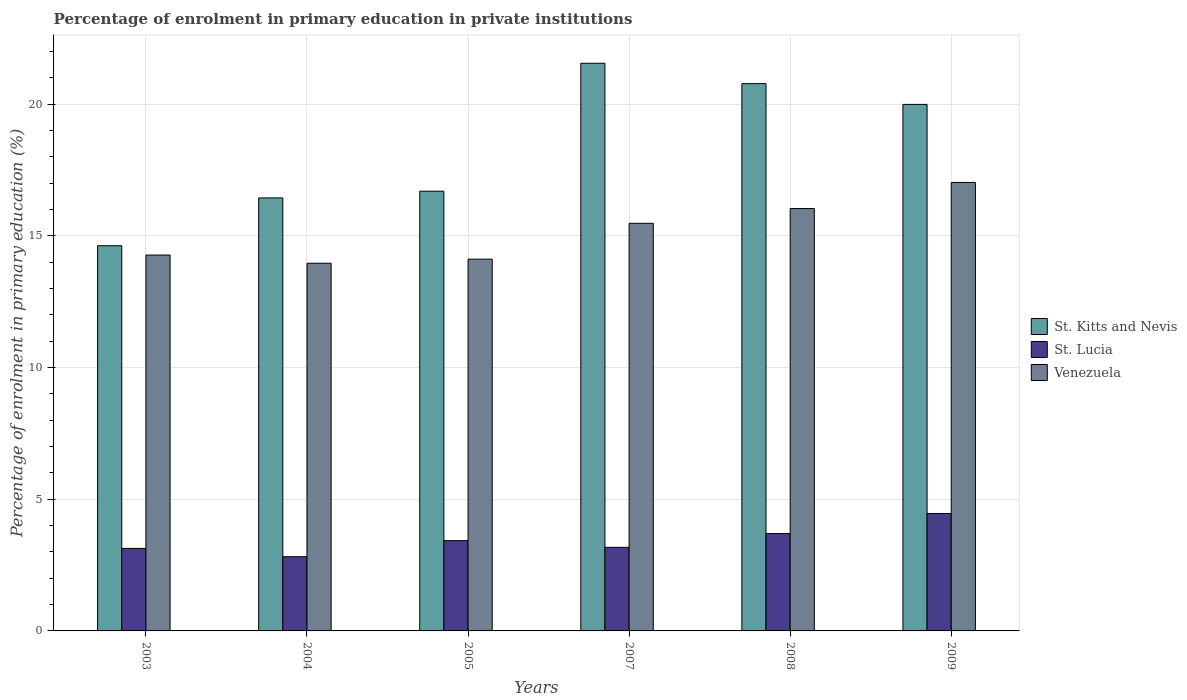How many groups of bars are there?
Your answer should be compact. 6. What is the percentage of enrolment in primary education in St. Kitts and Nevis in 2008?
Ensure brevity in your answer.  20.78. Across all years, what is the maximum percentage of enrolment in primary education in St. Kitts and Nevis?
Offer a terse response. 21.55. Across all years, what is the minimum percentage of enrolment in primary education in St. Kitts and Nevis?
Your answer should be very brief. 14.62. In which year was the percentage of enrolment in primary education in St. Kitts and Nevis minimum?
Make the answer very short. 2003. What is the total percentage of enrolment in primary education in St. Lucia in the graph?
Your answer should be compact. 20.71. What is the difference between the percentage of enrolment in primary education in Venezuela in 2003 and that in 2009?
Your answer should be very brief. -2.76. What is the difference between the percentage of enrolment in primary education in St. Kitts and Nevis in 2005 and the percentage of enrolment in primary education in St. Lucia in 2004?
Keep it short and to the point. 13.88. What is the average percentage of enrolment in primary education in Venezuela per year?
Offer a terse response. 15.15. In the year 2004, what is the difference between the percentage of enrolment in primary education in Venezuela and percentage of enrolment in primary education in St. Lucia?
Make the answer very short. 11.14. In how many years, is the percentage of enrolment in primary education in St. Lucia greater than 20 %?
Keep it short and to the point. 0. What is the ratio of the percentage of enrolment in primary education in St. Kitts and Nevis in 2003 to that in 2007?
Your answer should be very brief. 0.68. Is the percentage of enrolment in primary education in St. Kitts and Nevis in 2003 less than that in 2009?
Provide a succinct answer. Yes. What is the difference between the highest and the second highest percentage of enrolment in primary education in St. Lucia?
Your answer should be very brief. 0.76. What is the difference between the highest and the lowest percentage of enrolment in primary education in St. Kitts and Nevis?
Offer a terse response. 6.93. Is the sum of the percentage of enrolment in primary education in St. Lucia in 2003 and 2008 greater than the maximum percentage of enrolment in primary education in St. Kitts and Nevis across all years?
Keep it short and to the point. No. What does the 1st bar from the left in 2008 represents?
Make the answer very short. St. Kitts and Nevis. What does the 1st bar from the right in 2004 represents?
Give a very brief answer. Venezuela. How many bars are there?
Give a very brief answer. 18. Are all the bars in the graph horizontal?
Ensure brevity in your answer.  No. How many years are there in the graph?
Offer a very short reply. 6. What is the difference between two consecutive major ticks on the Y-axis?
Give a very brief answer. 5. Where does the legend appear in the graph?
Give a very brief answer. Center right. How many legend labels are there?
Ensure brevity in your answer.  3. What is the title of the graph?
Offer a very short reply. Percentage of enrolment in primary education in private institutions. Does "Jordan" appear as one of the legend labels in the graph?
Provide a short and direct response. No. What is the label or title of the X-axis?
Provide a succinct answer. Years. What is the label or title of the Y-axis?
Ensure brevity in your answer.  Percentage of enrolment in primary education (%). What is the Percentage of enrolment in primary education (%) in St. Kitts and Nevis in 2003?
Your answer should be compact. 14.62. What is the Percentage of enrolment in primary education (%) in St. Lucia in 2003?
Keep it short and to the point. 3.13. What is the Percentage of enrolment in primary education (%) in Venezuela in 2003?
Give a very brief answer. 14.27. What is the Percentage of enrolment in primary education (%) in St. Kitts and Nevis in 2004?
Your answer should be very brief. 16.44. What is the Percentage of enrolment in primary education (%) in St. Lucia in 2004?
Your answer should be very brief. 2.82. What is the Percentage of enrolment in primary education (%) in Venezuela in 2004?
Ensure brevity in your answer.  13.96. What is the Percentage of enrolment in primary education (%) in St. Kitts and Nevis in 2005?
Your answer should be compact. 16.69. What is the Percentage of enrolment in primary education (%) of St. Lucia in 2005?
Provide a succinct answer. 3.43. What is the Percentage of enrolment in primary education (%) of Venezuela in 2005?
Provide a succinct answer. 14.11. What is the Percentage of enrolment in primary education (%) in St. Kitts and Nevis in 2007?
Provide a succinct answer. 21.55. What is the Percentage of enrolment in primary education (%) in St. Lucia in 2007?
Make the answer very short. 3.17. What is the Percentage of enrolment in primary education (%) in Venezuela in 2007?
Give a very brief answer. 15.47. What is the Percentage of enrolment in primary education (%) of St. Kitts and Nevis in 2008?
Offer a very short reply. 20.78. What is the Percentage of enrolment in primary education (%) in St. Lucia in 2008?
Make the answer very short. 3.7. What is the Percentage of enrolment in primary education (%) of Venezuela in 2008?
Provide a succinct answer. 16.03. What is the Percentage of enrolment in primary education (%) of St. Kitts and Nevis in 2009?
Offer a very short reply. 19.99. What is the Percentage of enrolment in primary education (%) of St. Lucia in 2009?
Offer a very short reply. 4.46. What is the Percentage of enrolment in primary education (%) of Venezuela in 2009?
Your answer should be compact. 17.03. Across all years, what is the maximum Percentage of enrolment in primary education (%) in St. Kitts and Nevis?
Your answer should be very brief. 21.55. Across all years, what is the maximum Percentage of enrolment in primary education (%) of St. Lucia?
Offer a terse response. 4.46. Across all years, what is the maximum Percentage of enrolment in primary education (%) of Venezuela?
Provide a short and direct response. 17.03. Across all years, what is the minimum Percentage of enrolment in primary education (%) of St. Kitts and Nevis?
Your response must be concise. 14.62. Across all years, what is the minimum Percentage of enrolment in primary education (%) in St. Lucia?
Ensure brevity in your answer.  2.82. Across all years, what is the minimum Percentage of enrolment in primary education (%) of Venezuela?
Your response must be concise. 13.96. What is the total Percentage of enrolment in primary education (%) of St. Kitts and Nevis in the graph?
Offer a terse response. 110.06. What is the total Percentage of enrolment in primary education (%) of St. Lucia in the graph?
Your answer should be compact. 20.71. What is the total Percentage of enrolment in primary education (%) in Venezuela in the graph?
Your answer should be very brief. 90.87. What is the difference between the Percentage of enrolment in primary education (%) of St. Kitts and Nevis in 2003 and that in 2004?
Keep it short and to the point. -1.81. What is the difference between the Percentage of enrolment in primary education (%) of St. Lucia in 2003 and that in 2004?
Offer a terse response. 0.32. What is the difference between the Percentage of enrolment in primary education (%) of Venezuela in 2003 and that in 2004?
Ensure brevity in your answer.  0.31. What is the difference between the Percentage of enrolment in primary education (%) of St. Kitts and Nevis in 2003 and that in 2005?
Your response must be concise. -2.07. What is the difference between the Percentage of enrolment in primary education (%) of St. Lucia in 2003 and that in 2005?
Ensure brevity in your answer.  -0.29. What is the difference between the Percentage of enrolment in primary education (%) of Venezuela in 2003 and that in 2005?
Your answer should be very brief. 0.16. What is the difference between the Percentage of enrolment in primary education (%) of St. Kitts and Nevis in 2003 and that in 2007?
Your answer should be very brief. -6.93. What is the difference between the Percentage of enrolment in primary education (%) in St. Lucia in 2003 and that in 2007?
Your response must be concise. -0.04. What is the difference between the Percentage of enrolment in primary education (%) of Venezuela in 2003 and that in 2007?
Your answer should be very brief. -1.21. What is the difference between the Percentage of enrolment in primary education (%) of St. Kitts and Nevis in 2003 and that in 2008?
Provide a short and direct response. -6.15. What is the difference between the Percentage of enrolment in primary education (%) in St. Lucia in 2003 and that in 2008?
Your answer should be very brief. -0.56. What is the difference between the Percentage of enrolment in primary education (%) of Venezuela in 2003 and that in 2008?
Offer a very short reply. -1.76. What is the difference between the Percentage of enrolment in primary education (%) in St. Kitts and Nevis in 2003 and that in 2009?
Your answer should be compact. -5.36. What is the difference between the Percentage of enrolment in primary education (%) in St. Lucia in 2003 and that in 2009?
Ensure brevity in your answer.  -1.32. What is the difference between the Percentage of enrolment in primary education (%) of Venezuela in 2003 and that in 2009?
Offer a terse response. -2.76. What is the difference between the Percentage of enrolment in primary education (%) in St. Kitts and Nevis in 2004 and that in 2005?
Offer a terse response. -0.26. What is the difference between the Percentage of enrolment in primary education (%) in St. Lucia in 2004 and that in 2005?
Keep it short and to the point. -0.61. What is the difference between the Percentage of enrolment in primary education (%) in Venezuela in 2004 and that in 2005?
Provide a succinct answer. -0.16. What is the difference between the Percentage of enrolment in primary education (%) in St. Kitts and Nevis in 2004 and that in 2007?
Give a very brief answer. -5.11. What is the difference between the Percentage of enrolment in primary education (%) of St. Lucia in 2004 and that in 2007?
Keep it short and to the point. -0.36. What is the difference between the Percentage of enrolment in primary education (%) of Venezuela in 2004 and that in 2007?
Ensure brevity in your answer.  -1.52. What is the difference between the Percentage of enrolment in primary education (%) of St. Kitts and Nevis in 2004 and that in 2008?
Make the answer very short. -4.34. What is the difference between the Percentage of enrolment in primary education (%) of St. Lucia in 2004 and that in 2008?
Your answer should be compact. -0.88. What is the difference between the Percentage of enrolment in primary education (%) of Venezuela in 2004 and that in 2008?
Your answer should be very brief. -2.08. What is the difference between the Percentage of enrolment in primary education (%) of St. Kitts and Nevis in 2004 and that in 2009?
Your answer should be compact. -3.55. What is the difference between the Percentage of enrolment in primary education (%) in St. Lucia in 2004 and that in 2009?
Provide a short and direct response. -1.64. What is the difference between the Percentage of enrolment in primary education (%) of Venezuela in 2004 and that in 2009?
Give a very brief answer. -3.07. What is the difference between the Percentage of enrolment in primary education (%) in St. Kitts and Nevis in 2005 and that in 2007?
Your answer should be compact. -4.86. What is the difference between the Percentage of enrolment in primary education (%) of St. Lucia in 2005 and that in 2007?
Keep it short and to the point. 0.25. What is the difference between the Percentage of enrolment in primary education (%) in Venezuela in 2005 and that in 2007?
Your answer should be compact. -1.36. What is the difference between the Percentage of enrolment in primary education (%) in St. Kitts and Nevis in 2005 and that in 2008?
Provide a short and direct response. -4.08. What is the difference between the Percentage of enrolment in primary education (%) of St. Lucia in 2005 and that in 2008?
Make the answer very short. -0.27. What is the difference between the Percentage of enrolment in primary education (%) in Venezuela in 2005 and that in 2008?
Offer a very short reply. -1.92. What is the difference between the Percentage of enrolment in primary education (%) of St. Kitts and Nevis in 2005 and that in 2009?
Offer a very short reply. -3.29. What is the difference between the Percentage of enrolment in primary education (%) of St. Lucia in 2005 and that in 2009?
Keep it short and to the point. -1.03. What is the difference between the Percentage of enrolment in primary education (%) in Venezuela in 2005 and that in 2009?
Keep it short and to the point. -2.91. What is the difference between the Percentage of enrolment in primary education (%) in St. Kitts and Nevis in 2007 and that in 2008?
Your response must be concise. 0.77. What is the difference between the Percentage of enrolment in primary education (%) of St. Lucia in 2007 and that in 2008?
Offer a very short reply. -0.52. What is the difference between the Percentage of enrolment in primary education (%) in Venezuela in 2007 and that in 2008?
Offer a terse response. -0.56. What is the difference between the Percentage of enrolment in primary education (%) in St. Kitts and Nevis in 2007 and that in 2009?
Provide a short and direct response. 1.56. What is the difference between the Percentage of enrolment in primary education (%) in St. Lucia in 2007 and that in 2009?
Offer a very short reply. -1.29. What is the difference between the Percentage of enrolment in primary education (%) in Venezuela in 2007 and that in 2009?
Your answer should be compact. -1.55. What is the difference between the Percentage of enrolment in primary education (%) of St. Kitts and Nevis in 2008 and that in 2009?
Provide a short and direct response. 0.79. What is the difference between the Percentage of enrolment in primary education (%) of St. Lucia in 2008 and that in 2009?
Your response must be concise. -0.76. What is the difference between the Percentage of enrolment in primary education (%) of Venezuela in 2008 and that in 2009?
Ensure brevity in your answer.  -0.99. What is the difference between the Percentage of enrolment in primary education (%) of St. Kitts and Nevis in 2003 and the Percentage of enrolment in primary education (%) of St. Lucia in 2004?
Make the answer very short. 11.81. What is the difference between the Percentage of enrolment in primary education (%) in St. Kitts and Nevis in 2003 and the Percentage of enrolment in primary education (%) in Venezuela in 2004?
Your answer should be compact. 0.67. What is the difference between the Percentage of enrolment in primary education (%) of St. Lucia in 2003 and the Percentage of enrolment in primary education (%) of Venezuela in 2004?
Provide a short and direct response. -10.82. What is the difference between the Percentage of enrolment in primary education (%) in St. Kitts and Nevis in 2003 and the Percentage of enrolment in primary education (%) in St. Lucia in 2005?
Keep it short and to the point. 11.2. What is the difference between the Percentage of enrolment in primary education (%) of St. Kitts and Nevis in 2003 and the Percentage of enrolment in primary education (%) of Venezuela in 2005?
Your answer should be compact. 0.51. What is the difference between the Percentage of enrolment in primary education (%) in St. Lucia in 2003 and the Percentage of enrolment in primary education (%) in Venezuela in 2005?
Give a very brief answer. -10.98. What is the difference between the Percentage of enrolment in primary education (%) in St. Kitts and Nevis in 2003 and the Percentage of enrolment in primary education (%) in St. Lucia in 2007?
Provide a short and direct response. 11.45. What is the difference between the Percentage of enrolment in primary education (%) of St. Kitts and Nevis in 2003 and the Percentage of enrolment in primary education (%) of Venezuela in 2007?
Ensure brevity in your answer.  -0.85. What is the difference between the Percentage of enrolment in primary education (%) in St. Lucia in 2003 and the Percentage of enrolment in primary education (%) in Venezuela in 2007?
Offer a terse response. -12.34. What is the difference between the Percentage of enrolment in primary education (%) of St. Kitts and Nevis in 2003 and the Percentage of enrolment in primary education (%) of St. Lucia in 2008?
Your answer should be very brief. 10.93. What is the difference between the Percentage of enrolment in primary education (%) of St. Kitts and Nevis in 2003 and the Percentage of enrolment in primary education (%) of Venezuela in 2008?
Your response must be concise. -1.41. What is the difference between the Percentage of enrolment in primary education (%) in St. Lucia in 2003 and the Percentage of enrolment in primary education (%) in Venezuela in 2008?
Make the answer very short. -12.9. What is the difference between the Percentage of enrolment in primary education (%) in St. Kitts and Nevis in 2003 and the Percentage of enrolment in primary education (%) in St. Lucia in 2009?
Make the answer very short. 10.16. What is the difference between the Percentage of enrolment in primary education (%) of St. Kitts and Nevis in 2003 and the Percentage of enrolment in primary education (%) of Venezuela in 2009?
Offer a terse response. -2.4. What is the difference between the Percentage of enrolment in primary education (%) of St. Lucia in 2003 and the Percentage of enrolment in primary education (%) of Venezuela in 2009?
Make the answer very short. -13.89. What is the difference between the Percentage of enrolment in primary education (%) in St. Kitts and Nevis in 2004 and the Percentage of enrolment in primary education (%) in St. Lucia in 2005?
Your answer should be compact. 13.01. What is the difference between the Percentage of enrolment in primary education (%) of St. Kitts and Nevis in 2004 and the Percentage of enrolment in primary education (%) of Venezuela in 2005?
Offer a very short reply. 2.32. What is the difference between the Percentage of enrolment in primary education (%) of St. Lucia in 2004 and the Percentage of enrolment in primary education (%) of Venezuela in 2005?
Your answer should be compact. -11.3. What is the difference between the Percentage of enrolment in primary education (%) in St. Kitts and Nevis in 2004 and the Percentage of enrolment in primary education (%) in St. Lucia in 2007?
Your answer should be compact. 13.26. What is the difference between the Percentage of enrolment in primary education (%) of St. Kitts and Nevis in 2004 and the Percentage of enrolment in primary education (%) of Venezuela in 2007?
Your response must be concise. 0.96. What is the difference between the Percentage of enrolment in primary education (%) of St. Lucia in 2004 and the Percentage of enrolment in primary education (%) of Venezuela in 2007?
Ensure brevity in your answer.  -12.66. What is the difference between the Percentage of enrolment in primary education (%) in St. Kitts and Nevis in 2004 and the Percentage of enrolment in primary education (%) in St. Lucia in 2008?
Make the answer very short. 12.74. What is the difference between the Percentage of enrolment in primary education (%) of St. Kitts and Nevis in 2004 and the Percentage of enrolment in primary education (%) of Venezuela in 2008?
Provide a short and direct response. 0.4. What is the difference between the Percentage of enrolment in primary education (%) of St. Lucia in 2004 and the Percentage of enrolment in primary education (%) of Venezuela in 2008?
Your answer should be compact. -13.22. What is the difference between the Percentage of enrolment in primary education (%) in St. Kitts and Nevis in 2004 and the Percentage of enrolment in primary education (%) in St. Lucia in 2009?
Give a very brief answer. 11.98. What is the difference between the Percentage of enrolment in primary education (%) of St. Kitts and Nevis in 2004 and the Percentage of enrolment in primary education (%) of Venezuela in 2009?
Your answer should be very brief. -0.59. What is the difference between the Percentage of enrolment in primary education (%) of St. Lucia in 2004 and the Percentage of enrolment in primary education (%) of Venezuela in 2009?
Make the answer very short. -14.21. What is the difference between the Percentage of enrolment in primary education (%) of St. Kitts and Nevis in 2005 and the Percentage of enrolment in primary education (%) of St. Lucia in 2007?
Offer a very short reply. 13.52. What is the difference between the Percentage of enrolment in primary education (%) of St. Kitts and Nevis in 2005 and the Percentage of enrolment in primary education (%) of Venezuela in 2007?
Give a very brief answer. 1.22. What is the difference between the Percentage of enrolment in primary education (%) in St. Lucia in 2005 and the Percentage of enrolment in primary education (%) in Venezuela in 2007?
Keep it short and to the point. -12.05. What is the difference between the Percentage of enrolment in primary education (%) in St. Kitts and Nevis in 2005 and the Percentage of enrolment in primary education (%) in St. Lucia in 2008?
Ensure brevity in your answer.  13. What is the difference between the Percentage of enrolment in primary education (%) of St. Kitts and Nevis in 2005 and the Percentage of enrolment in primary education (%) of Venezuela in 2008?
Your answer should be compact. 0.66. What is the difference between the Percentage of enrolment in primary education (%) in St. Lucia in 2005 and the Percentage of enrolment in primary education (%) in Venezuela in 2008?
Offer a very short reply. -12.61. What is the difference between the Percentage of enrolment in primary education (%) in St. Kitts and Nevis in 2005 and the Percentage of enrolment in primary education (%) in St. Lucia in 2009?
Ensure brevity in your answer.  12.23. What is the difference between the Percentage of enrolment in primary education (%) in St. Kitts and Nevis in 2005 and the Percentage of enrolment in primary education (%) in Venezuela in 2009?
Ensure brevity in your answer.  -0.33. What is the difference between the Percentage of enrolment in primary education (%) of St. Lucia in 2005 and the Percentage of enrolment in primary education (%) of Venezuela in 2009?
Give a very brief answer. -13.6. What is the difference between the Percentage of enrolment in primary education (%) in St. Kitts and Nevis in 2007 and the Percentage of enrolment in primary education (%) in St. Lucia in 2008?
Give a very brief answer. 17.85. What is the difference between the Percentage of enrolment in primary education (%) in St. Kitts and Nevis in 2007 and the Percentage of enrolment in primary education (%) in Venezuela in 2008?
Give a very brief answer. 5.51. What is the difference between the Percentage of enrolment in primary education (%) in St. Lucia in 2007 and the Percentage of enrolment in primary education (%) in Venezuela in 2008?
Your answer should be very brief. -12.86. What is the difference between the Percentage of enrolment in primary education (%) of St. Kitts and Nevis in 2007 and the Percentage of enrolment in primary education (%) of St. Lucia in 2009?
Make the answer very short. 17.09. What is the difference between the Percentage of enrolment in primary education (%) in St. Kitts and Nevis in 2007 and the Percentage of enrolment in primary education (%) in Venezuela in 2009?
Offer a terse response. 4.52. What is the difference between the Percentage of enrolment in primary education (%) in St. Lucia in 2007 and the Percentage of enrolment in primary education (%) in Venezuela in 2009?
Give a very brief answer. -13.85. What is the difference between the Percentage of enrolment in primary education (%) in St. Kitts and Nevis in 2008 and the Percentage of enrolment in primary education (%) in St. Lucia in 2009?
Make the answer very short. 16.32. What is the difference between the Percentage of enrolment in primary education (%) of St. Kitts and Nevis in 2008 and the Percentage of enrolment in primary education (%) of Venezuela in 2009?
Offer a terse response. 3.75. What is the difference between the Percentage of enrolment in primary education (%) of St. Lucia in 2008 and the Percentage of enrolment in primary education (%) of Venezuela in 2009?
Give a very brief answer. -13.33. What is the average Percentage of enrolment in primary education (%) in St. Kitts and Nevis per year?
Offer a very short reply. 18.34. What is the average Percentage of enrolment in primary education (%) of St. Lucia per year?
Your response must be concise. 3.45. What is the average Percentage of enrolment in primary education (%) in Venezuela per year?
Your response must be concise. 15.15. In the year 2003, what is the difference between the Percentage of enrolment in primary education (%) in St. Kitts and Nevis and Percentage of enrolment in primary education (%) in St. Lucia?
Offer a terse response. 11.49. In the year 2003, what is the difference between the Percentage of enrolment in primary education (%) of St. Kitts and Nevis and Percentage of enrolment in primary education (%) of Venezuela?
Ensure brevity in your answer.  0.35. In the year 2003, what is the difference between the Percentage of enrolment in primary education (%) in St. Lucia and Percentage of enrolment in primary education (%) in Venezuela?
Ensure brevity in your answer.  -11.14. In the year 2004, what is the difference between the Percentage of enrolment in primary education (%) of St. Kitts and Nevis and Percentage of enrolment in primary education (%) of St. Lucia?
Keep it short and to the point. 13.62. In the year 2004, what is the difference between the Percentage of enrolment in primary education (%) in St. Kitts and Nevis and Percentage of enrolment in primary education (%) in Venezuela?
Provide a succinct answer. 2.48. In the year 2004, what is the difference between the Percentage of enrolment in primary education (%) of St. Lucia and Percentage of enrolment in primary education (%) of Venezuela?
Your response must be concise. -11.14. In the year 2005, what is the difference between the Percentage of enrolment in primary education (%) of St. Kitts and Nevis and Percentage of enrolment in primary education (%) of St. Lucia?
Provide a succinct answer. 13.27. In the year 2005, what is the difference between the Percentage of enrolment in primary education (%) in St. Kitts and Nevis and Percentage of enrolment in primary education (%) in Venezuela?
Your answer should be very brief. 2.58. In the year 2005, what is the difference between the Percentage of enrolment in primary education (%) in St. Lucia and Percentage of enrolment in primary education (%) in Venezuela?
Give a very brief answer. -10.68. In the year 2007, what is the difference between the Percentage of enrolment in primary education (%) in St. Kitts and Nevis and Percentage of enrolment in primary education (%) in St. Lucia?
Provide a succinct answer. 18.38. In the year 2007, what is the difference between the Percentage of enrolment in primary education (%) in St. Kitts and Nevis and Percentage of enrolment in primary education (%) in Venezuela?
Make the answer very short. 6.07. In the year 2007, what is the difference between the Percentage of enrolment in primary education (%) in St. Lucia and Percentage of enrolment in primary education (%) in Venezuela?
Make the answer very short. -12.3. In the year 2008, what is the difference between the Percentage of enrolment in primary education (%) in St. Kitts and Nevis and Percentage of enrolment in primary education (%) in St. Lucia?
Provide a short and direct response. 17.08. In the year 2008, what is the difference between the Percentage of enrolment in primary education (%) of St. Kitts and Nevis and Percentage of enrolment in primary education (%) of Venezuela?
Provide a short and direct response. 4.74. In the year 2008, what is the difference between the Percentage of enrolment in primary education (%) of St. Lucia and Percentage of enrolment in primary education (%) of Venezuela?
Your answer should be compact. -12.34. In the year 2009, what is the difference between the Percentage of enrolment in primary education (%) in St. Kitts and Nevis and Percentage of enrolment in primary education (%) in St. Lucia?
Ensure brevity in your answer.  15.53. In the year 2009, what is the difference between the Percentage of enrolment in primary education (%) in St. Kitts and Nevis and Percentage of enrolment in primary education (%) in Venezuela?
Provide a succinct answer. 2.96. In the year 2009, what is the difference between the Percentage of enrolment in primary education (%) in St. Lucia and Percentage of enrolment in primary education (%) in Venezuela?
Keep it short and to the point. -12.57. What is the ratio of the Percentage of enrolment in primary education (%) of St. Kitts and Nevis in 2003 to that in 2004?
Provide a succinct answer. 0.89. What is the ratio of the Percentage of enrolment in primary education (%) in St. Lucia in 2003 to that in 2004?
Ensure brevity in your answer.  1.11. What is the ratio of the Percentage of enrolment in primary education (%) in Venezuela in 2003 to that in 2004?
Offer a very short reply. 1.02. What is the ratio of the Percentage of enrolment in primary education (%) of St. Kitts and Nevis in 2003 to that in 2005?
Offer a terse response. 0.88. What is the ratio of the Percentage of enrolment in primary education (%) of St. Lucia in 2003 to that in 2005?
Your answer should be very brief. 0.91. What is the ratio of the Percentage of enrolment in primary education (%) of Venezuela in 2003 to that in 2005?
Your answer should be very brief. 1.01. What is the ratio of the Percentage of enrolment in primary education (%) in St. Kitts and Nevis in 2003 to that in 2007?
Provide a short and direct response. 0.68. What is the ratio of the Percentage of enrolment in primary education (%) of St. Lucia in 2003 to that in 2007?
Your response must be concise. 0.99. What is the ratio of the Percentage of enrolment in primary education (%) of Venezuela in 2003 to that in 2007?
Offer a very short reply. 0.92. What is the ratio of the Percentage of enrolment in primary education (%) in St. Kitts and Nevis in 2003 to that in 2008?
Make the answer very short. 0.7. What is the ratio of the Percentage of enrolment in primary education (%) in St. Lucia in 2003 to that in 2008?
Your answer should be very brief. 0.85. What is the ratio of the Percentage of enrolment in primary education (%) in Venezuela in 2003 to that in 2008?
Your answer should be compact. 0.89. What is the ratio of the Percentage of enrolment in primary education (%) in St. Kitts and Nevis in 2003 to that in 2009?
Your answer should be very brief. 0.73. What is the ratio of the Percentage of enrolment in primary education (%) of St. Lucia in 2003 to that in 2009?
Ensure brevity in your answer.  0.7. What is the ratio of the Percentage of enrolment in primary education (%) in Venezuela in 2003 to that in 2009?
Make the answer very short. 0.84. What is the ratio of the Percentage of enrolment in primary education (%) of St. Kitts and Nevis in 2004 to that in 2005?
Provide a succinct answer. 0.98. What is the ratio of the Percentage of enrolment in primary education (%) of St. Lucia in 2004 to that in 2005?
Your answer should be very brief. 0.82. What is the ratio of the Percentage of enrolment in primary education (%) of Venezuela in 2004 to that in 2005?
Offer a terse response. 0.99. What is the ratio of the Percentage of enrolment in primary education (%) of St. Kitts and Nevis in 2004 to that in 2007?
Keep it short and to the point. 0.76. What is the ratio of the Percentage of enrolment in primary education (%) in St. Lucia in 2004 to that in 2007?
Ensure brevity in your answer.  0.89. What is the ratio of the Percentage of enrolment in primary education (%) in Venezuela in 2004 to that in 2007?
Give a very brief answer. 0.9. What is the ratio of the Percentage of enrolment in primary education (%) of St. Kitts and Nevis in 2004 to that in 2008?
Offer a very short reply. 0.79. What is the ratio of the Percentage of enrolment in primary education (%) in St. Lucia in 2004 to that in 2008?
Provide a succinct answer. 0.76. What is the ratio of the Percentage of enrolment in primary education (%) of Venezuela in 2004 to that in 2008?
Give a very brief answer. 0.87. What is the ratio of the Percentage of enrolment in primary education (%) in St. Kitts and Nevis in 2004 to that in 2009?
Give a very brief answer. 0.82. What is the ratio of the Percentage of enrolment in primary education (%) of St. Lucia in 2004 to that in 2009?
Offer a terse response. 0.63. What is the ratio of the Percentage of enrolment in primary education (%) in Venezuela in 2004 to that in 2009?
Your answer should be compact. 0.82. What is the ratio of the Percentage of enrolment in primary education (%) of St. Kitts and Nevis in 2005 to that in 2007?
Your response must be concise. 0.77. What is the ratio of the Percentage of enrolment in primary education (%) of St. Lucia in 2005 to that in 2007?
Provide a short and direct response. 1.08. What is the ratio of the Percentage of enrolment in primary education (%) in Venezuela in 2005 to that in 2007?
Keep it short and to the point. 0.91. What is the ratio of the Percentage of enrolment in primary education (%) in St. Kitts and Nevis in 2005 to that in 2008?
Provide a succinct answer. 0.8. What is the ratio of the Percentage of enrolment in primary education (%) of St. Lucia in 2005 to that in 2008?
Give a very brief answer. 0.93. What is the ratio of the Percentage of enrolment in primary education (%) in Venezuela in 2005 to that in 2008?
Make the answer very short. 0.88. What is the ratio of the Percentage of enrolment in primary education (%) of St. Kitts and Nevis in 2005 to that in 2009?
Keep it short and to the point. 0.84. What is the ratio of the Percentage of enrolment in primary education (%) of St. Lucia in 2005 to that in 2009?
Provide a succinct answer. 0.77. What is the ratio of the Percentage of enrolment in primary education (%) in Venezuela in 2005 to that in 2009?
Provide a short and direct response. 0.83. What is the ratio of the Percentage of enrolment in primary education (%) of St. Kitts and Nevis in 2007 to that in 2008?
Offer a very short reply. 1.04. What is the ratio of the Percentage of enrolment in primary education (%) in St. Lucia in 2007 to that in 2008?
Provide a succinct answer. 0.86. What is the ratio of the Percentage of enrolment in primary education (%) of Venezuela in 2007 to that in 2008?
Provide a succinct answer. 0.97. What is the ratio of the Percentage of enrolment in primary education (%) in St. Kitts and Nevis in 2007 to that in 2009?
Your answer should be compact. 1.08. What is the ratio of the Percentage of enrolment in primary education (%) of St. Lucia in 2007 to that in 2009?
Provide a succinct answer. 0.71. What is the ratio of the Percentage of enrolment in primary education (%) in Venezuela in 2007 to that in 2009?
Keep it short and to the point. 0.91. What is the ratio of the Percentage of enrolment in primary education (%) in St. Kitts and Nevis in 2008 to that in 2009?
Your answer should be very brief. 1.04. What is the ratio of the Percentage of enrolment in primary education (%) of St. Lucia in 2008 to that in 2009?
Give a very brief answer. 0.83. What is the ratio of the Percentage of enrolment in primary education (%) of Venezuela in 2008 to that in 2009?
Provide a short and direct response. 0.94. What is the difference between the highest and the second highest Percentage of enrolment in primary education (%) in St. Kitts and Nevis?
Your answer should be compact. 0.77. What is the difference between the highest and the second highest Percentage of enrolment in primary education (%) of St. Lucia?
Provide a short and direct response. 0.76. What is the difference between the highest and the second highest Percentage of enrolment in primary education (%) of Venezuela?
Offer a terse response. 0.99. What is the difference between the highest and the lowest Percentage of enrolment in primary education (%) of St. Kitts and Nevis?
Offer a terse response. 6.93. What is the difference between the highest and the lowest Percentage of enrolment in primary education (%) of St. Lucia?
Give a very brief answer. 1.64. What is the difference between the highest and the lowest Percentage of enrolment in primary education (%) in Venezuela?
Provide a short and direct response. 3.07. 